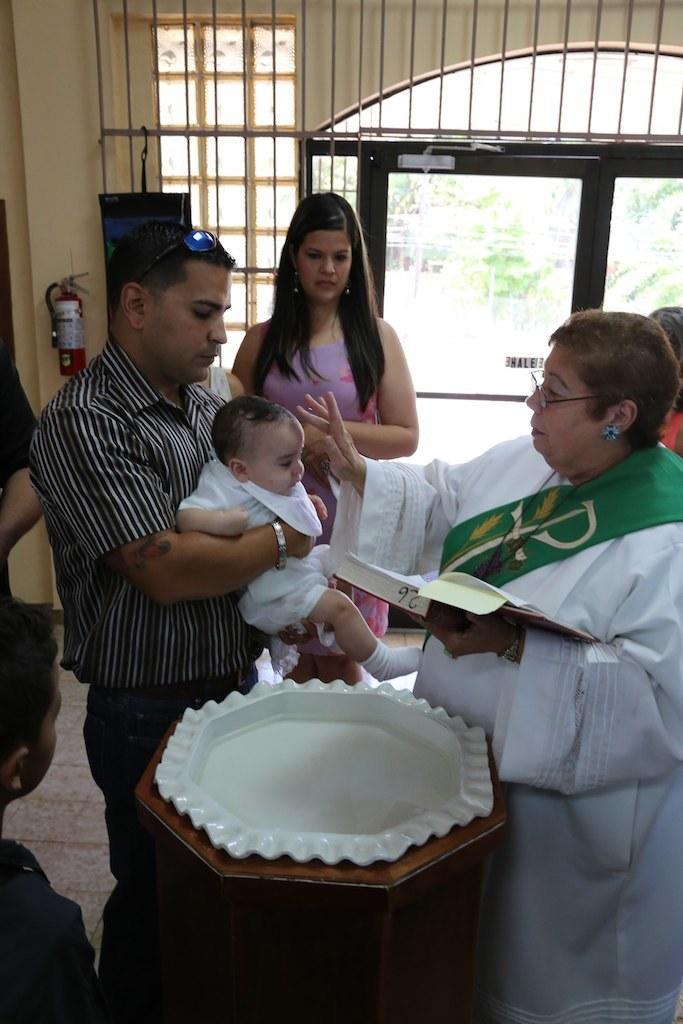Describe this image in one or two sentences. In this image, we can see a persons holding a baby with his hands. There is a person on the right side of the image holding a book. There is a bowl at the bottom of the image. There is a person in the middle of the image standing in front of the door. 